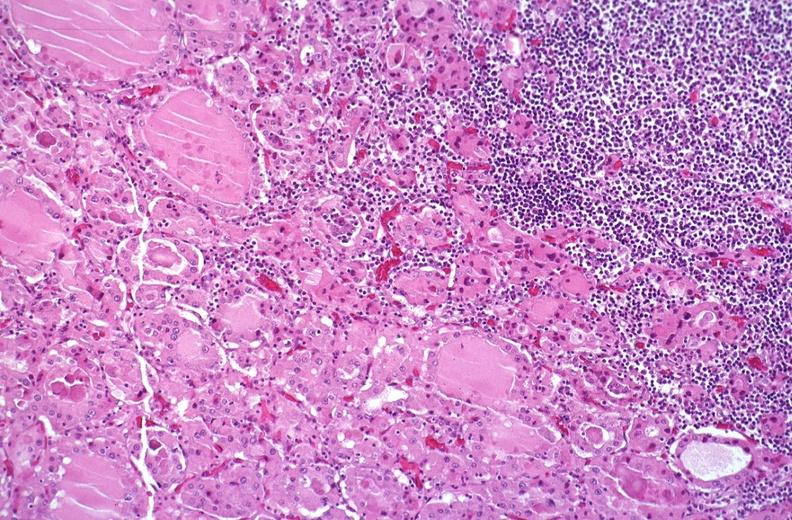where is this part in the figure?
Answer the question using a single word or phrase. Endocrine system 